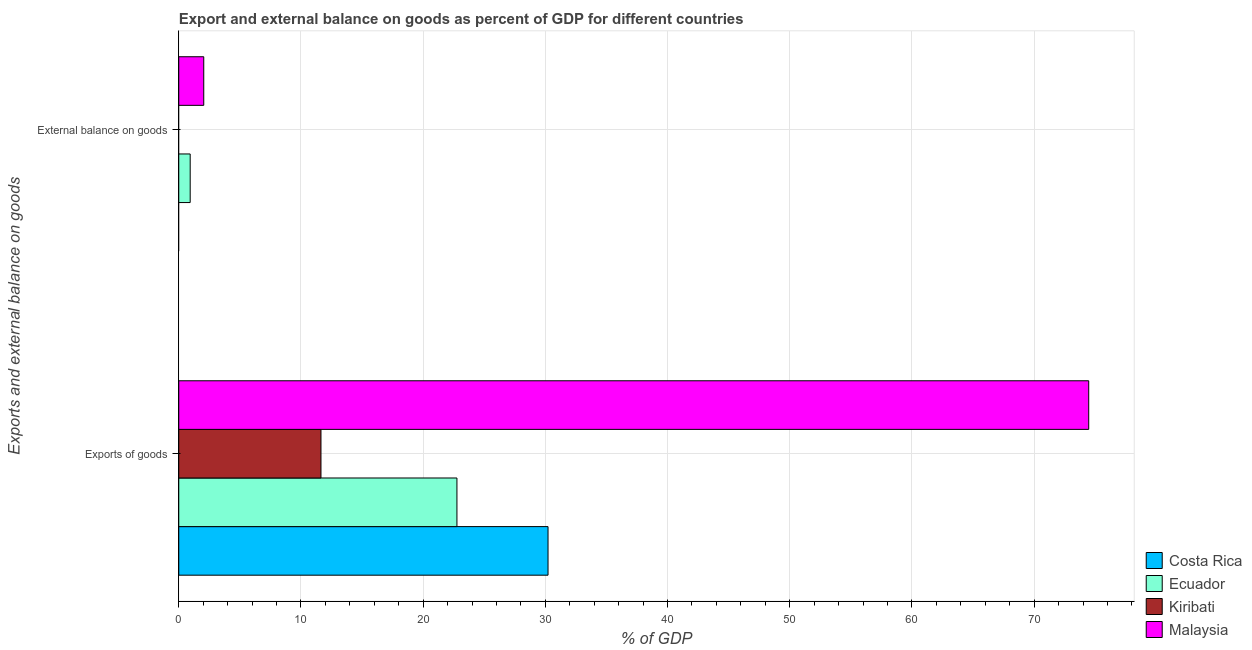Are the number of bars per tick equal to the number of legend labels?
Offer a terse response. No. Are the number of bars on each tick of the Y-axis equal?
Offer a very short reply. No. How many bars are there on the 1st tick from the top?
Offer a very short reply. 2. How many bars are there on the 1st tick from the bottom?
Provide a short and direct response. 4. What is the label of the 1st group of bars from the top?
Make the answer very short. External balance on goods. Across all countries, what is the maximum external balance on goods as percentage of gdp?
Make the answer very short. 2.04. Across all countries, what is the minimum export of goods as percentage of gdp?
Keep it short and to the point. 11.64. In which country was the export of goods as percentage of gdp maximum?
Provide a succinct answer. Malaysia. What is the total external balance on goods as percentage of gdp in the graph?
Ensure brevity in your answer.  2.98. What is the difference between the export of goods as percentage of gdp in Malaysia and that in Kiribati?
Your answer should be very brief. 62.83. What is the difference between the external balance on goods as percentage of gdp in Malaysia and the export of goods as percentage of gdp in Ecuador?
Provide a succinct answer. -20.72. What is the average export of goods as percentage of gdp per country?
Keep it short and to the point. 34.77. What is the difference between the external balance on goods as percentage of gdp and export of goods as percentage of gdp in Malaysia?
Your answer should be very brief. -72.42. What is the ratio of the external balance on goods as percentage of gdp in Malaysia to that in Ecuador?
Provide a short and direct response. 2.19. Is the export of goods as percentage of gdp in Kiribati less than that in Costa Rica?
Ensure brevity in your answer.  Yes. How many bars are there?
Your answer should be compact. 6. Are the values on the major ticks of X-axis written in scientific E-notation?
Offer a terse response. No. Does the graph contain any zero values?
Keep it short and to the point. Yes. Does the graph contain grids?
Provide a succinct answer. Yes. Where does the legend appear in the graph?
Provide a succinct answer. Bottom right. How many legend labels are there?
Offer a terse response. 4. What is the title of the graph?
Make the answer very short. Export and external balance on goods as percent of GDP for different countries. What is the label or title of the X-axis?
Offer a terse response. % of GDP. What is the label or title of the Y-axis?
Your answer should be very brief. Exports and external balance on goods. What is the % of GDP of Costa Rica in Exports of goods?
Your response must be concise. 30.22. What is the % of GDP of Ecuador in Exports of goods?
Your answer should be very brief. 22.76. What is the % of GDP of Kiribati in Exports of goods?
Provide a short and direct response. 11.64. What is the % of GDP of Malaysia in Exports of goods?
Make the answer very short. 74.47. What is the % of GDP in Ecuador in External balance on goods?
Provide a short and direct response. 0.93. What is the % of GDP of Malaysia in External balance on goods?
Your response must be concise. 2.04. Across all Exports and external balance on goods, what is the maximum % of GDP in Costa Rica?
Provide a succinct answer. 30.22. Across all Exports and external balance on goods, what is the maximum % of GDP in Ecuador?
Keep it short and to the point. 22.76. Across all Exports and external balance on goods, what is the maximum % of GDP of Kiribati?
Your response must be concise. 11.64. Across all Exports and external balance on goods, what is the maximum % of GDP in Malaysia?
Give a very brief answer. 74.47. Across all Exports and external balance on goods, what is the minimum % of GDP in Costa Rica?
Ensure brevity in your answer.  0. Across all Exports and external balance on goods, what is the minimum % of GDP of Ecuador?
Give a very brief answer. 0.93. Across all Exports and external balance on goods, what is the minimum % of GDP of Malaysia?
Provide a short and direct response. 2.04. What is the total % of GDP in Costa Rica in the graph?
Offer a terse response. 30.22. What is the total % of GDP in Ecuador in the graph?
Provide a short and direct response. 23.7. What is the total % of GDP of Kiribati in the graph?
Give a very brief answer. 11.64. What is the total % of GDP of Malaysia in the graph?
Your answer should be compact. 76.51. What is the difference between the % of GDP of Ecuador in Exports of goods and that in External balance on goods?
Offer a terse response. 21.83. What is the difference between the % of GDP of Malaysia in Exports of goods and that in External balance on goods?
Offer a terse response. 72.42. What is the difference between the % of GDP of Costa Rica in Exports of goods and the % of GDP of Ecuador in External balance on goods?
Provide a succinct answer. 29.29. What is the difference between the % of GDP in Costa Rica in Exports of goods and the % of GDP in Malaysia in External balance on goods?
Your response must be concise. 28.17. What is the difference between the % of GDP in Ecuador in Exports of goods and the % of GDP in Malaysia in External balance on goods?
Give a very brief answer. 20.72. What is the difference between the % of GDP of Kiribati in Exports of goods and the % of GDP of Malaysia in External balance on goods?
Your response must be concise. 9.59. What is the average % of GDP of Costa Rica per Exports and external balance on goods?
Offer a very short reply. 15.11. What is the average % of GDP of Ecuador per Exports and external balance on goods?
Offer a terse response. 11.85. What is the average % of GDP in Kiribati per Exports and external balance on goods?
Offer a very short reply. 5.82. What is the average % of GDP in Malaysia per Exports and external balance on goods?
Provide a succinct answer. 38.26. What is the difference between the % of GDP in Costa Rica and % of GDP in Ecuador in Exports of goods?
Your response must be concise. 7.45. What is the difference between the % of GDP of Costa Rica and % of GDP of Kiribati in Exports of goods?
Give a very brief answer. 18.58. What is the difference between the % of GDP of Costa Rica and % of GDP of Malaysia in Exports of goods?
Provide a short and direct response. -44.25. What is the difference between the % of GDP of Ecuador and % of GDP of Kiribati in Exports of goods?
Give a very brief answer. 11.13. What is the difference between the % of GDP in Ecuador and % of GDP in Malaysia in Exports of goods?
Your answer should be compact. -51.7. What is the difference between the % of GDP of Kiribati and % of GDP of Malaysia in Exports of goods?
Your answer should be compact. -62.83. What is the difference between the % of GDP of Ecuador and % of GDP of Malaysia in External balance on goods?
Your response must be concise. -1.11. What is the ratio of the % of GDP of Ecuador in Exports of goods to that in External balance on goods?
Provide a succinct answer. 24.38. What is the ratio of the % of GDP of Malaysia in Exports of goods to that in External balance on goods?
Give a very brief answer. 36.43. What is the difference between the highest and the second highest % of GDP in Ecuador?
Give a very brief answer. 21.83. What is the difference between the highest and the second highest % of GDP of Malaysia?
Provide a short and direct response. 72.42. What is the difference between the highest and the lowest % of GDP in Costa Rica?
Your answer should be compact. 30.22. What is the difference between the highest and the lowest % of GDP of Ecuador?
Offer a very short reply. 21.83. What is the difference between the highest and the lowest % of GDP in Kiribati?
Give a very brief answer. 11.64. What is the difference between the highest and the lowest % of GDP of Malaysia?
Give a very brief answer. 72.42. 